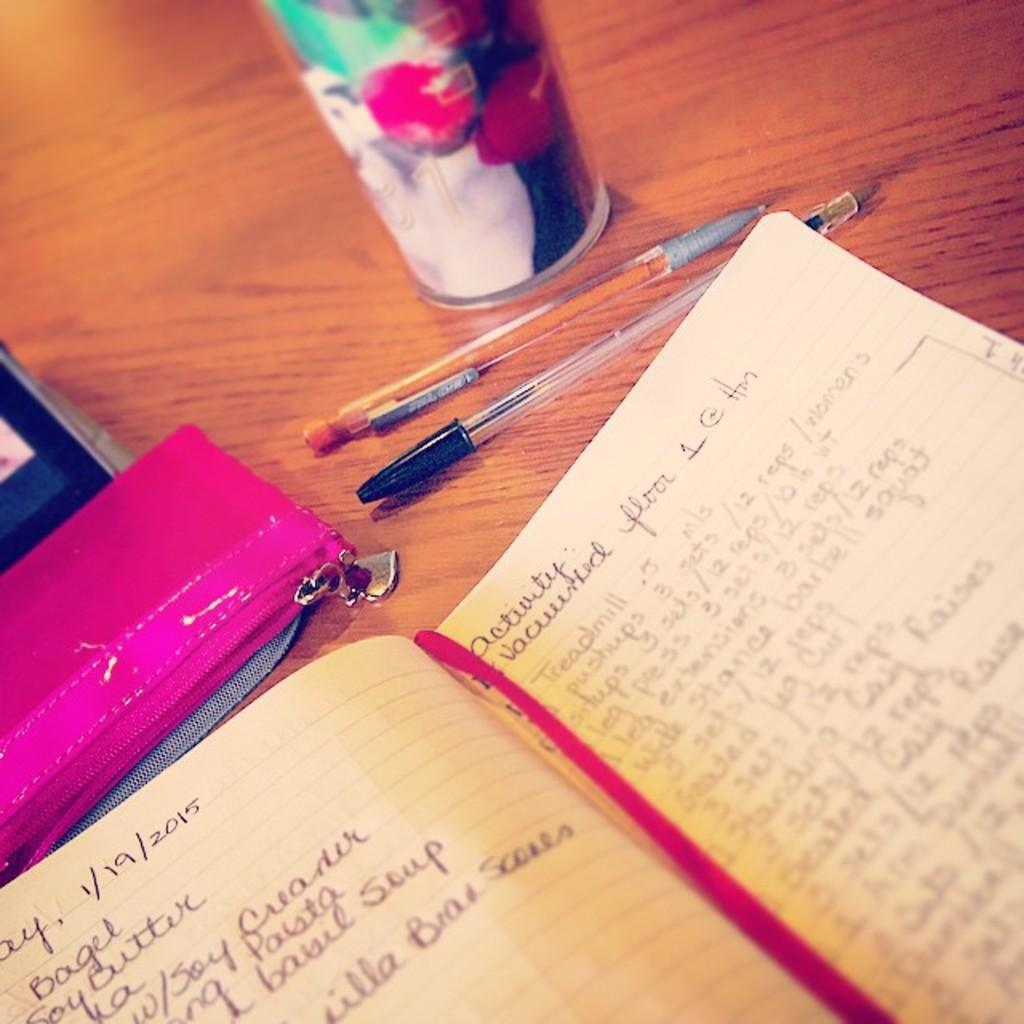What piece of furniture is present in the image? There is a table in the image. What items can be seen on the table? There is a book, a wallet, pens, and a glass on the table. What might be used for writing in the image? The pens on the table can be used for writing. What type of badge is visible on the book in the image? There is no badge present on the book or any other item in the image. What scientific theory is being discussed in the image? There is no indication of a scientific theory being discussed in the image. 